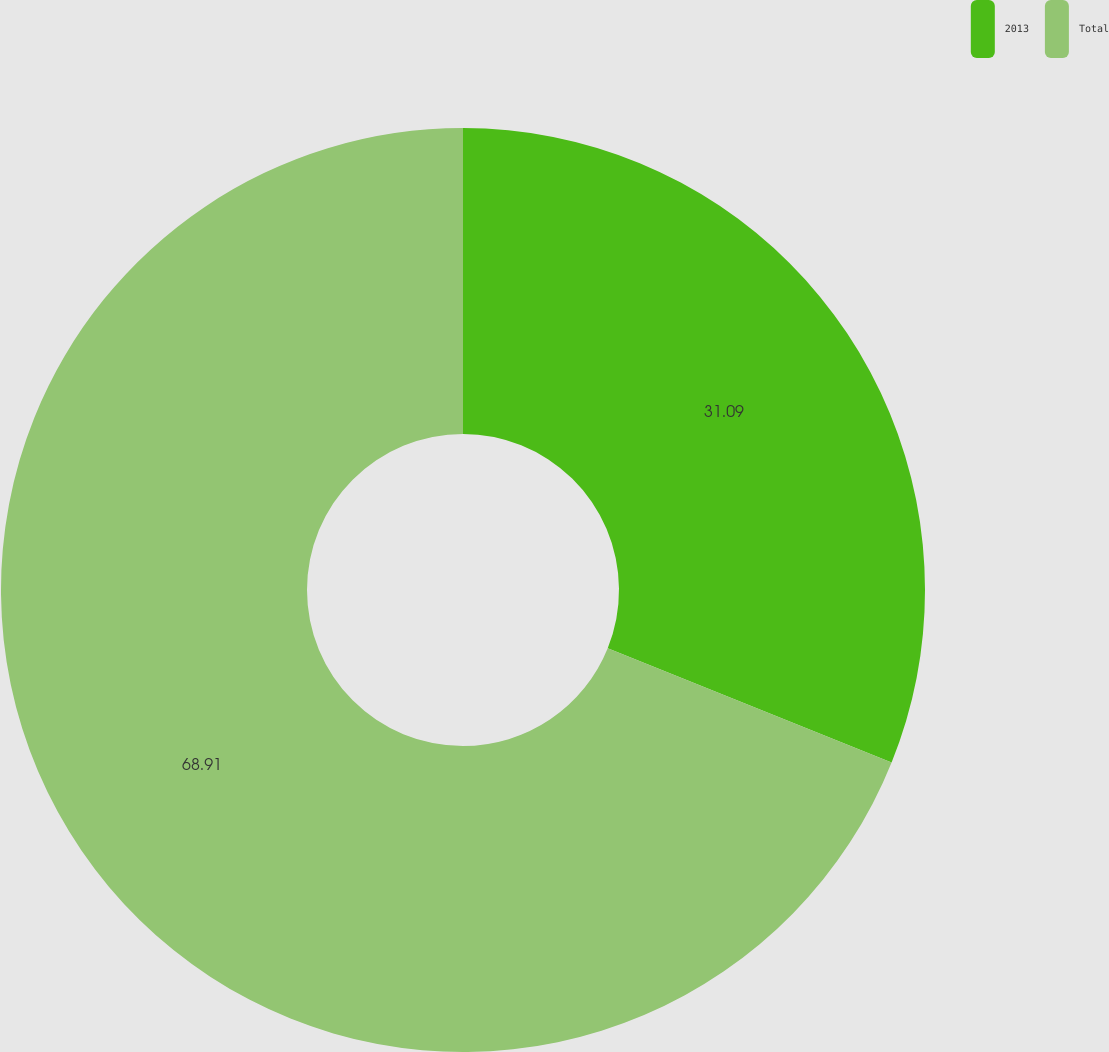<chart> <loc_0><loc_0><loc_500><loc_500><pie_chart><fcel>2013<fcel>Total<nl><fcel>31.09%<fcel>68.91%<nl></chart> 